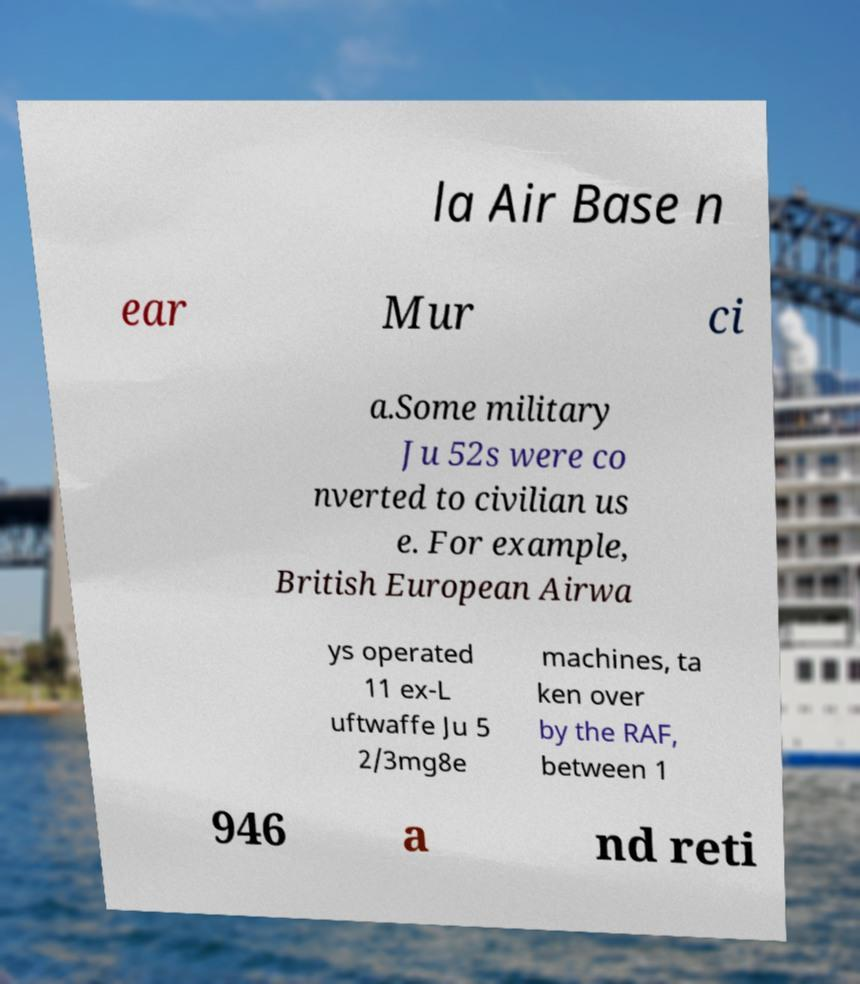Please read and relay the text visible in this image. What does it say? la Air Base n ear Mur ci a.Some military Ju 52s were co nverted to civilian us e. For example, British European Airwa ys operated 11 ex-L uftwaffe Ju 5 2/3mg8e machines, ta ken over by the RAF, between 1 946 a nd reti 